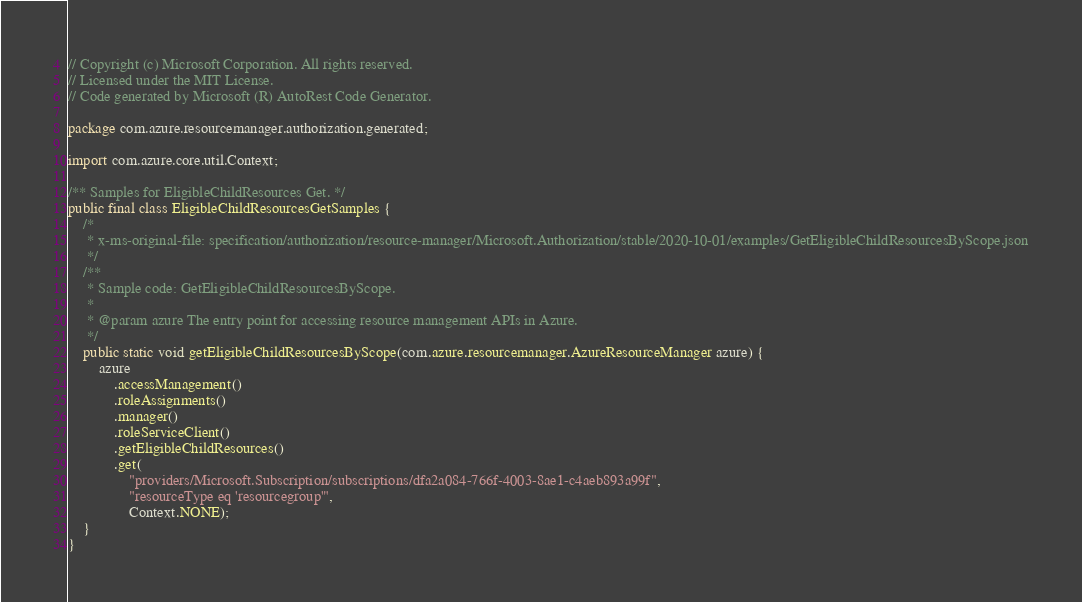<code> <loc_0><loc_0><loc_500><loc_500><_Java_>// Copyright (c) Microsoft Corporation. All rights reserved.
// Licensed under the MIT License.
// Code generated by Microsoft (R) AutoRest Code Generator.

package com.azure.resourcemanager.authorization.generated;

import com.azure.core.util.Context;

/** Samples for EligibleChildResources Get. */
public final class EligibleChildResourcesGetSamples {
    /*
     * x-ms-original-file: specification/authorization/resource-manager/Microsoft.Authorization/stable/2020-10-01/examples/GetEligibleChildResourcesByScope.json
     */
    /**
     * Sample code: GetEligibleChildResourcesByScope.
     *
     * @param azure The entry point for accessing resource management APIs in Azure.
     */
    public static void getEligibleChildResourcesByScope(com.azure.resourcemanager.AzureResourceManager azure) {
        azure
            .accessManagement()
            .roleAssignments()
            .manager()
            .roleServiceClient()
            .getEligibleChildResources()
            .get(
                "providers/Microsoft.Subscription/subscriptions/dfa2a084-766f-4003-8ae1-c4aeb893a99f",
                "resourceType eq 'resourcegroup'",
                Context.NONE);
    }
}
</code> 